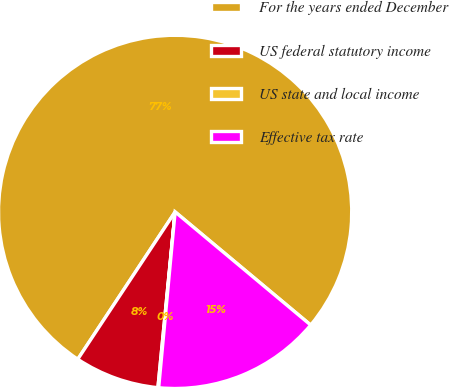Convert chart. <chart><loc_0><loc_0><loc_500><loc_500><pie_chart><fcel>For the years ended December<fcel>US federal statutory income<fcel>US state and local income<fcel>Effective tax rate<nl><fcel>76.77%<fcel>7.74%<fcel>0.07%<fcel>15.41%<nl></chart> 